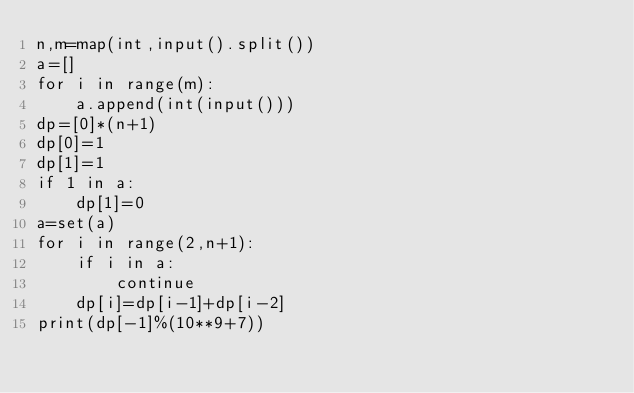Convert code to text. <code><loc_0><loc_0><loc_500><loc_500><_Python_>n,m=map(int,input().split())
a=[]
for i in range(m):
    a.append(int(input()))
dp=[0]*(n+1)
dp[0]=1
dp[1]=1
if 1 in a:
    dp[1]=0
a=set(a)
for i in range(2,n+1):
    if i in a:
        continue
    dp[i]=dp[i-1]+dp[i-2]
print(dp[-1]%(10**9+7))</code> 